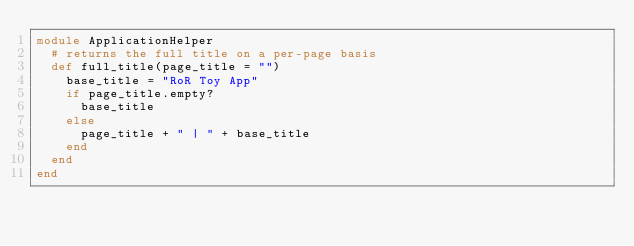Convert code to text. <code><loc_0><loc_0><loc_500><loc_500><_Ruby_>module ApplicationHelper
  # returns the full title on a per-page basis
  def full_title(page_title = "")
    base_title = "RoR Toy App"
    if page_title.empty?
      base_title
    else
      page_title + " | " + base_title
    end
  end
end
</code> 